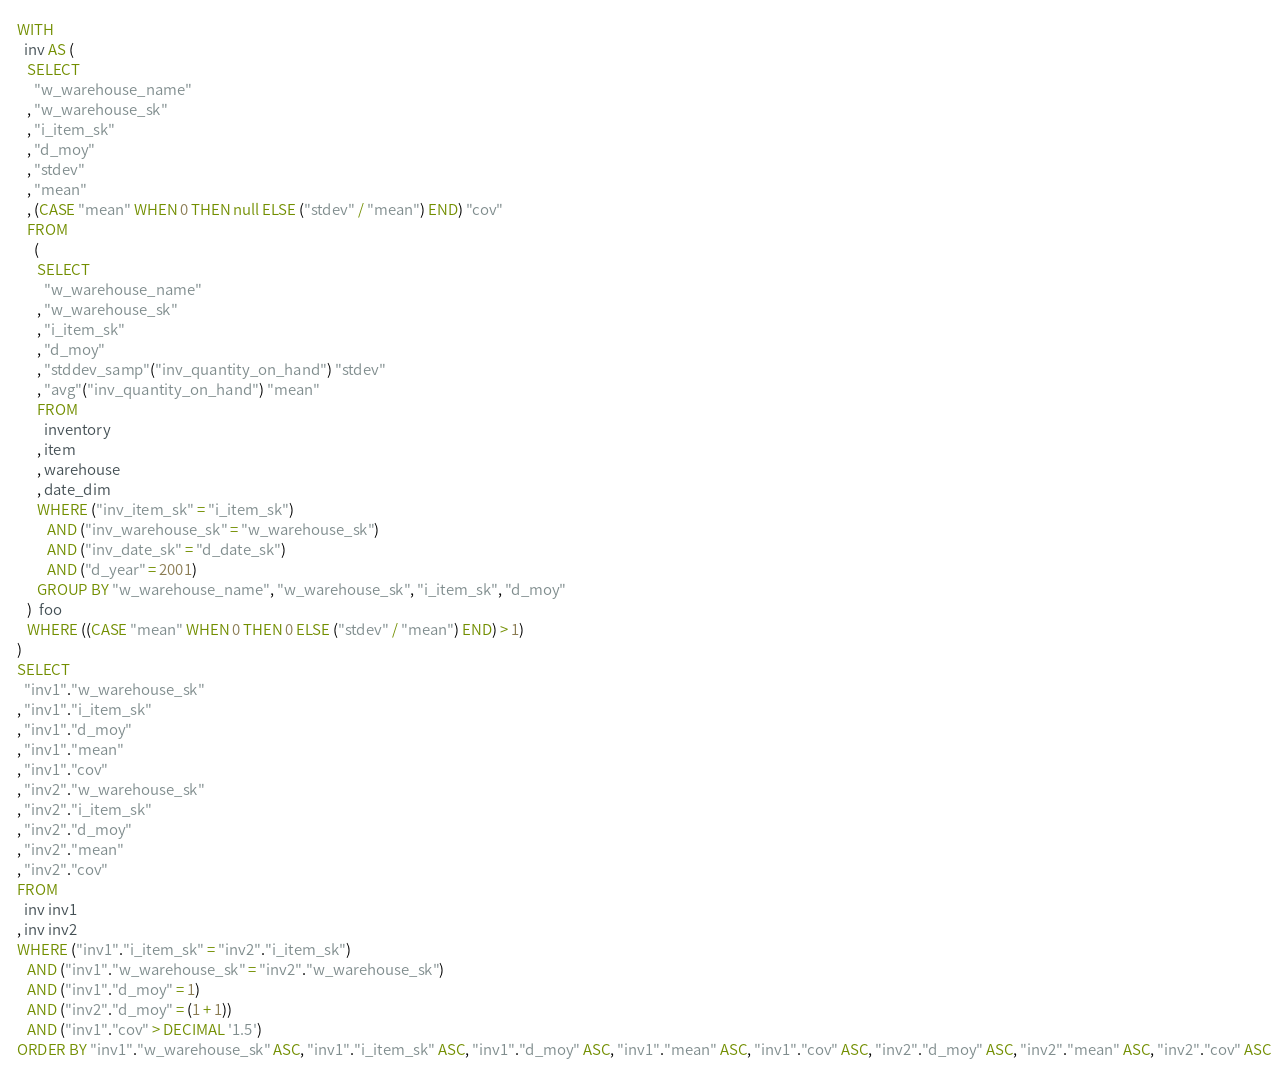Convert code to text. <code><loc_0><loc_0><loc_500><loc_500><_SQL_>WITH
  inv AS (
   SELECT
     "w_warehouse_name"
   , "w_warehouse_sk"
   , "i_item_sk"
   , "d_moy"
   , "stdev"
   , "mean"
   , (CASE "mean" WHEN 0 THEN null ELSE ("stdev" / "mean") END) "cov"
   FROM
     (
      SELECT
        "w_warehouse_name"
      , "w_warehouse_sk"
      , "i_item_sk"
      , "d_moy"
      , "stddev_samp"("inv_quantity_on_hand") "stdev"
      , "avg"("inv_quantity_on_hand") "mean"
      FROM
        inventory
      , item
      , warehouse
      , date_dim
      WHERE ("inv_item_sk" = "i_item_sk")
         AND ("inv_warehouse_sk" = "w_warehouse_sk")
         AND ("inv_date_sk" = "d_date_sk")
         AND ("d_year" = 2001)
      GROUP BY "w_warehouse_name", "w_warehouse_sk", "i_item_sk", "d_moy"
   )  foo
   WHERE ((CASE "mean" WHEN 0 THEN 0 ELSE ("stdev" / "mean") END) > 1)
)
SELECT
  "inv1"."w_warehouse_sk"
, "inv1"."i_item_sk"
, "inv1"."d_moy"
, "inv1"."mean"
, "inv1"."cov"
, "inv2"."w_warehouse_sk"
, "inv2"."i_item_sk"
, "inv2"."d_moy"
, "inv2"."mean"
, "inv2"."cov"
FROM
  inv inv1
, inv inv2
WHERE ("inv1"."i_item_sk" = "inv2"."i_item_sk")
   AND ("inv1"."w_warehouse_sk" = "inv2"."w_warehouse_sk")
   AND ("inv1"."d_moy" = 1)
   AND ("inv2"."d_moy" = (1 + 1))
   AND ("inv1"."cov" > DECIMAL '1.5')
ORDER BY "inv1"."w_warehouse_sk" ASC, "inv1"."i_item_sk" ASC, "inv1"."d_moy" ASC, "inv1"."mean" ASC, "inv1"."cov" ASC, "inv2"."d_moy" ASC, "inv2"."mean" ASC, "inv2"."cov" ASC
</code> 